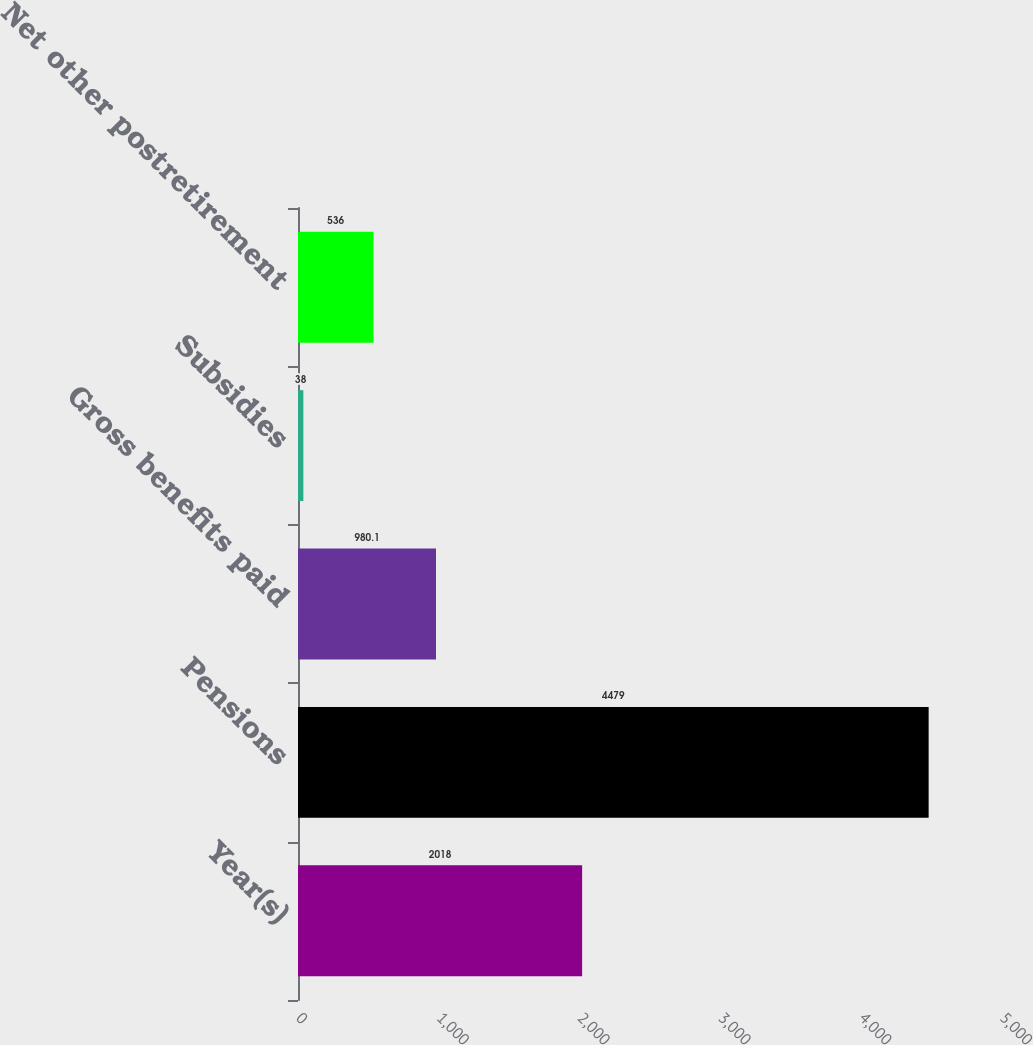<chart> <loc_0><loc_0><loc_500><loc_500><bar_chart><fcel>Year(s)<fcel>Pensions<fcel>Gross benefits paid<fcel>Subsidies<fcel>Net other postretirement<nl><fcel>2018<fcel>4479<fcel>980.1<fcel>38<fcel>536<nl></chart> 